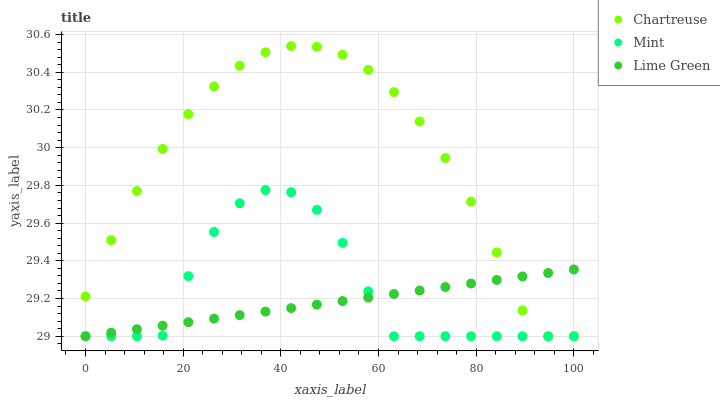Does Lime Green have the minimum area under the curve?
Answer yes or no. Yes. Does Chartreuse have the maximum area under the curve?
Answer yes or no. Yes. Does Mint have the minimum area under the curve?
Answer yes or no. No. Does Mint have the maximum area under the curve?
Answer yes or no. No. Is Lime Green the smoothest?
Answer yes or no. Yes. Is Mint the roughest?
Answer yes or no. Yes. Is Chartreuse the smoothest?
Answer yes or no. No. Is Chartreuse the roughest?
Answer yes or no. No. Does Lime Green have the lowest value?
Answer yes or no. Yes. Does Chartreuse have the highest value?
Answer yes or no. Yes. Does Mint have the highest value?
Answer yes or no. No. Does Chartreuse intersect Mint?
Answer yes or no. Yes. Is Chartreuse less than Mint?
Answer yes or no. No. Is Chartreuse greater than Mint?
Answer yes or no. No. 